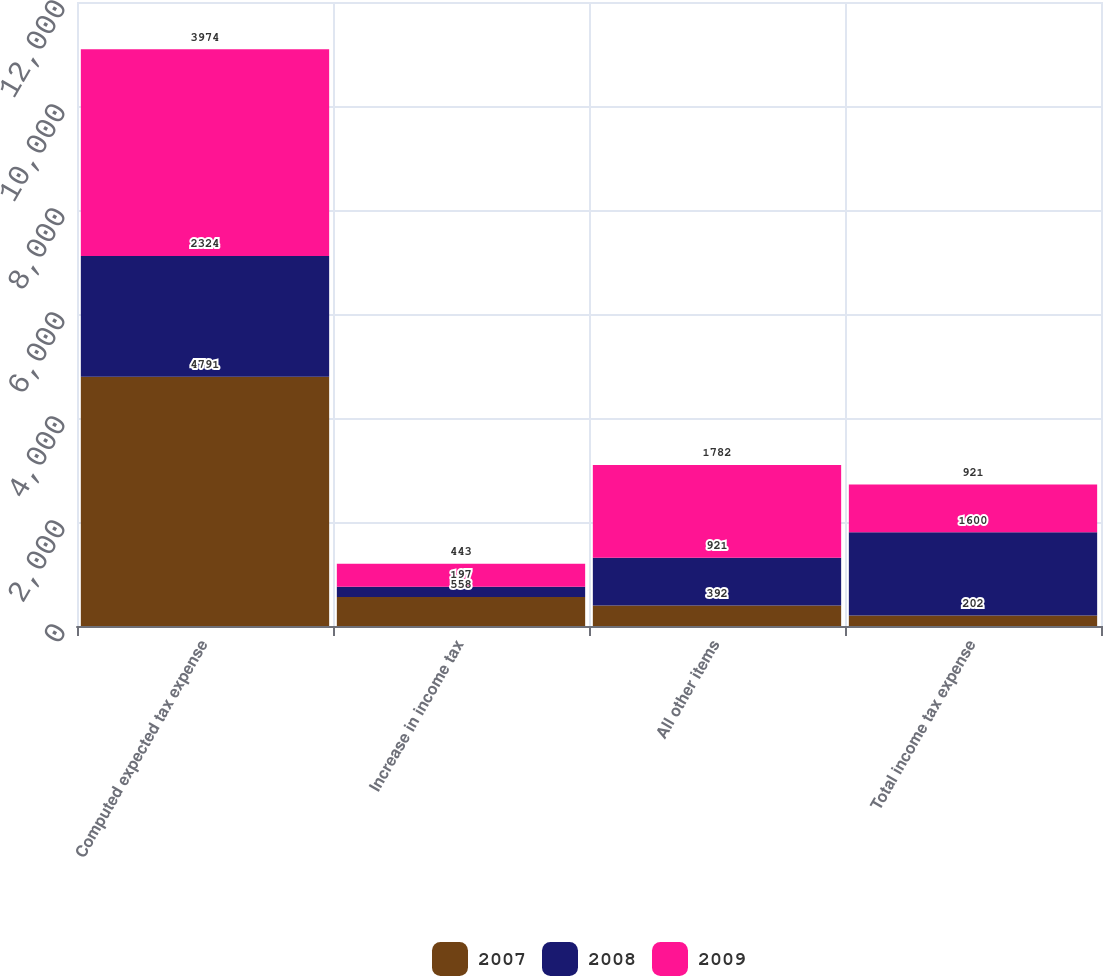Convert chart to OTSL. <chart><loc_0><loc_0><loc_500><loc_500><stacked_bar_chart><ecel><fcel>Computed expected tax expense<fcel>Increase in income tax<fcel>All other items<fcel>Total income tax expense<nl><fcel>2007<fcel>4791<fcel>558<fcel>392<fcel>202<nl><fcel>2008<fcel>2324<fcel>197<fcel>921<fcel>1600<nl><fcel>2009<fcel>3974<fcel>443<fcel>1782<fcel>921<nl></chart> 